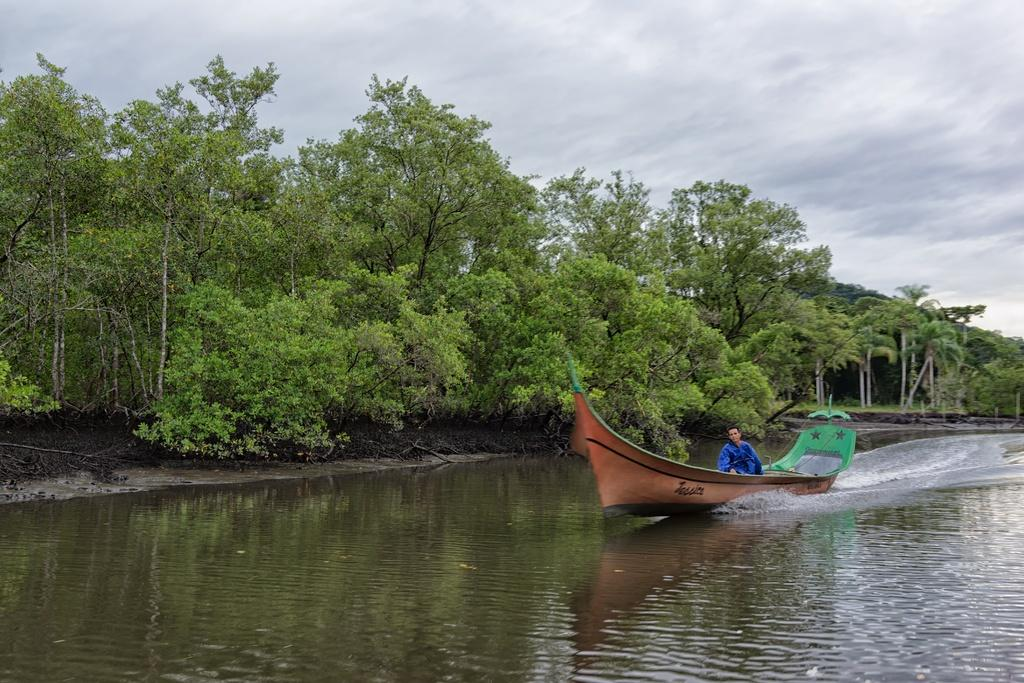What is located on the right side of the image? There is a man in a boat on the right side of the image. What can be seen at the bottom of the image? There is water visible at the bottom of the image. What type of vegetation is in the middle of the image? There are trees in the middle of the image. What is the condition of the sky in the image? The sky is cloudy and visible at the top of the image. What type of oatmeal is being served to the beggar in the image? There is no beggar or oatmeal present in the image. 